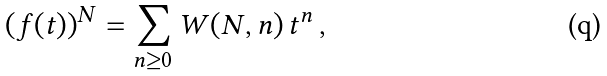Convert formula to latex. <formula><loc_0><loc_0><loc_500><loc_500>\left ( f ( t ) \right ) ^ { N } = \sum _ { n \geq 0 } W ( N , n ) \, t ^ { n } \, ,</formula> 